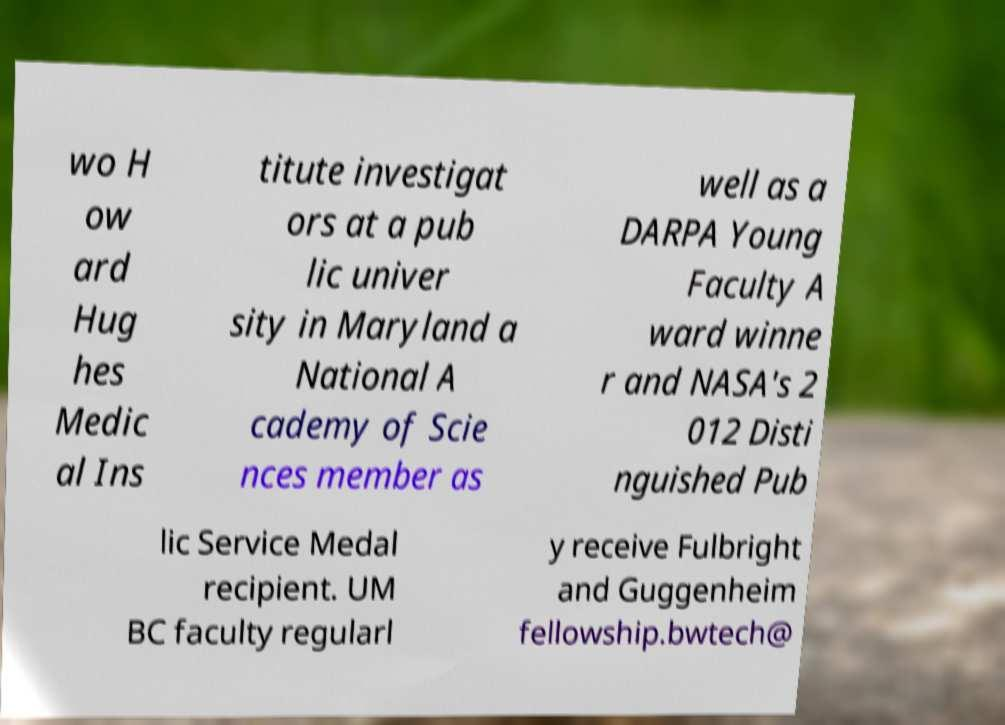Please identify and transcribe the text found in this image. wo H ow ard Hug hes Medic al Ins titute investigat ors at a pub lic univer sity in Maryland a National A cademy of Scie nces member as well as a DARPA Young Faculty A ward winne r and NASA's 2 012 Disti nguished Pub lic Service Medal recipient. UM BC faculty regularl y receive Fulbright and Guggenheim fellowship.bwtech@ 